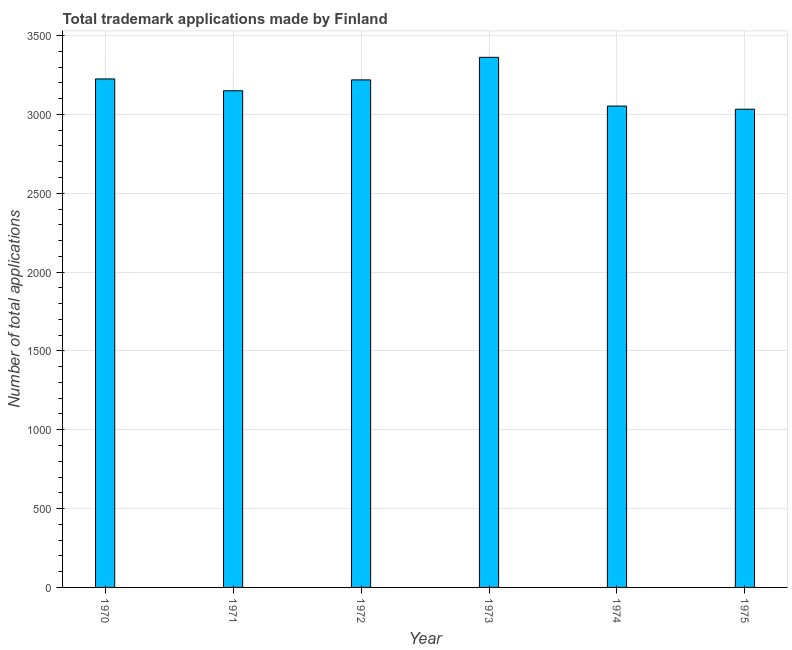Does the graph contain any zero values?
Make the answer very short. No. Does the graph contain grids?
Give a very brief answer. Yes. What is the title of the graph?
Give a very brief answer. Total trademark applications made by Finland. What is the label or title of the Y-axis?
Keep it short and to the point. Number of total applications. What is the number of trademark applications in 1970?
Keep it short and to the point. 3225. Across all years, what is the maximum number of trademark applications?
Give a very brief answer. 3362. Across all years, what is the minimum number of trademark applications?
Your response must be concise. 3033. In which year was the number of trademark applications maximum?
Ensure brevity in your answer.  1973. In which year was the number of trademark applications minimum?
Your answer should be compact. 1975. What is the sum of the number of trademark applications?
Offer a very short reply. 1.90e+04. What is the difference between the number of trademark applications in 1971 and 1974?
Provide a succinct answer. 97. What is the average number of trademark applications per year?
Offer a very short reply. 3173. What is the median number of trademark applications?
Offer a very short reply. 3184.5. Do a majority of the years between 1975 and 1971 (inclusive) have number of trademark applications greater than 300 ?
Make the answer very short. Yes. What is the ratio of the number of trademark applications in 1970 to that in 1971?
Your response must be concise. 1.02. Is the difference between the number of trademark applications in 1972 and 1974 greater than the difference between any two years?
Give a very brief answer. No. What is the difference between the highest and the second highest number of trademark applications?
Your answer should be very brief. 137. Is the sum of the number of trademark applications in 1973 and 1975 greater than the maximum number of trademark applications across all years?
Provide a succinct answer. Yes. What is the difference between the highest and the lowest number of trademark applications?
Ensure brevity in your answer.  329. How many bars are there?
Make the answer very short. 6. What is the Number of total applications in 1970?
Your answer should be compact. 3225. What is the Number of total applications of 1971?
Keep it short and to the point. 3150. What is the Number of total applications in 1972?
Your answer should be compact. 3219. What is the Number of total applications of 1973?
Ensure brevity in your answer.  3362. What is the Number of total applications of 1974?
Your answer should be very brief. 3053. What is the Number of total applications in 1975?
Give a very brief answer. 3033. What is the difference between the Number of total applications in 1970 and 1972?
Give a very brief answer. 6. What is the difference between the Number of total applications in 1970 and 1973?
Keep it short and to the point. -137. What is the difference between the Number of total applications in 1970 and 1974?
Make the answer very short. 172. What is the difference between the Number of total applications in 1970 and 1975?
Make the answer very short. 192. What is the difference between the Number of total applications in 1971 and 1972?
Offer a terse response. -69. What is the difference between the Number of total applications in 1971 and 1973?
Offer a terse response. -212. What is the difference between the Number of total applications in 1971 and 1974?
Keep it short and to the point. 97. What is the difference between the Number of total applications in 1971 and 1975?
Provide a short and direct response. 117. What is the difference between the Number of total applications in 1972 and 1973?
Your response must be concise. -143. What is the difference between the Number of total applications in 1972 and 1974?
Your response must be concise. 166. What is the difference between the Number of total applications in 1972 and 1975?
Offer a terse response. 186. What is the difference between the Number of total applications in 1973 and 1974?
Your answer should be very brief. 309. What is the difference between the Number of total applications in 1973 and 1975?
Make the answer very short. 329. What is the difference between the Number of total applications in 1974 and 1975?
Offer a terse response. 20. What is the ratio of the Number of total applications in 1970 to that in 1974?
Offer a very short reply. 1.06. What is the ratio of the Number of total applications in 1970 to that in 1975?
Your response must be concise. 1.06. What is the ratio of the Number of total applications in 1971 to that in 1972?
Your answer should be compact. 0.98. What is the ratio of the Number of total applications in 1971 to that in 1973?
Make the answer very short. 0.94. What is the ratio of the Number of total applications in 1971 to that in 1974?
Provide a short and direct response. 1.03. What is the ratio of the Number of total applications in 1971 to that in 1975?
Ensure brevity in your answer.  1.04. What is the ratio of the Number of total applications in 1972 to that in 1973?
Your answer should be very brief. 0.96. What is the ratio of the Number of total applications in 1972 to that in 1974?
Provide a short and direct response. 1.05. What is the ratio of the Number of total applications in 1972 to that in 1975?
Your answer should be compact. 1.06. What is the ratio of the Number of total applications in 1973 to that in 1974?
Provide a short and direct response. 1.1. What is the ratio of the Number of total applications in 1973 to that in 1975?
Offer a terse response. 1.11. 